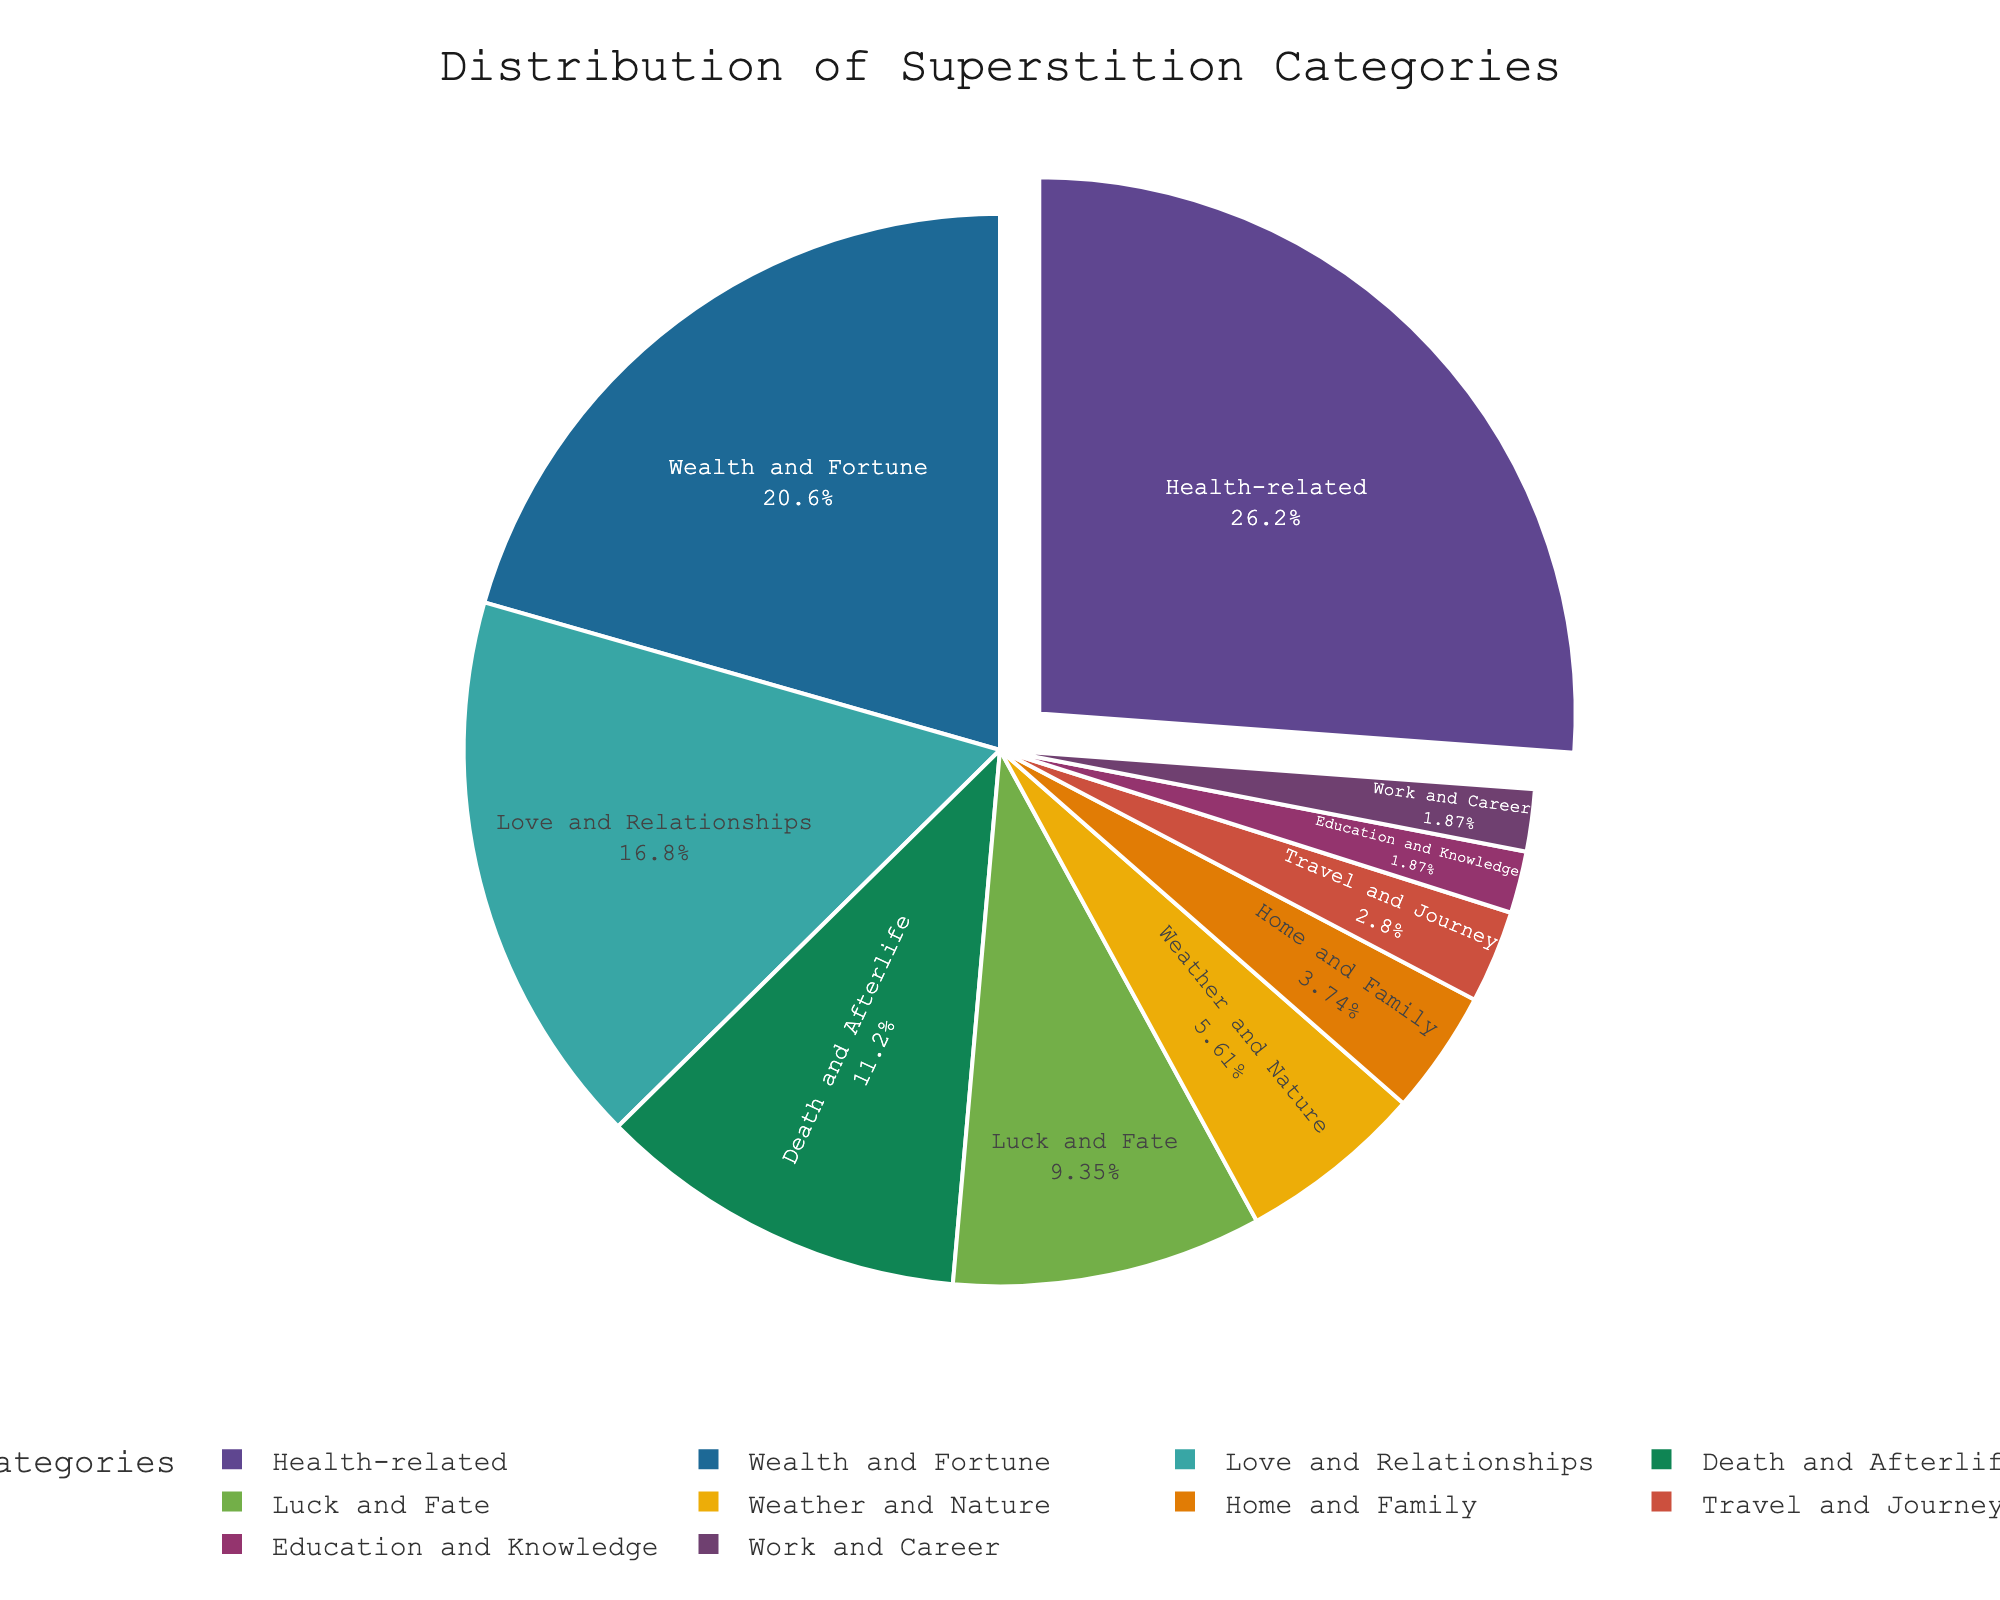What is the largest superstition category? The largest superstition category is represented by the largest slice of the pie chart. It is 'Health-related'.
Answer: Health-related Which category has the smallest proportion? The smallest proportion is represented by the smallest slice of the pie chart. It is 'Work and Career', represented by only 2%.
Answer: Work and Career What is the combined percentage of 'Health-related' and 'Wealth and Fortune'? The 'Health-related' category is 28% and 'Wealth and Fortune' is 22%. Combining these categories: 28% + 22% = 50%.
Answer: 50% Compare the percentages of 'Luck and Fate' and 'Love and Relationships'. Which one has a higher percentage? 'Luck and Fate' is 10% and 'Love and Relationships' is 18%. Since 18% is greater than 10%, 'Love and Relationships' has a higher percentage.
Answer: Love and Relationships Is the proportion of 'Weather and Nature' greater than 'Home and Family'? 'Weather and Nature' is 6% while 'Home and Family' is 4%. Since 6% is greater than 4%, 'Weather and Nature' has a greater proportion.
Answer: Yes What is the total percentage of categories related to personal matters ('Love and Relationships', 'Home and Family', 'Health-related')? The percentages are 18%, 4%, and 28% respectively. Summing these: 18% + 4% + 28% = 50%.
Answer: 50% How much smaller is the 'Education and Knowledge' category compared to 'Travel and Journey'? 'Education and Knowledge' is 2% and 'Travel and Journey' is 3%. The difference is 3% - 2% = 1%.
Answer: 1% Which categories have an equal percentage? The categories 'Education and Knowledge' and 'Work and Career' both are represented by 2%.
Answer: Education and Knowledge, Work and Career What is the visual difference between the slices representing 'Health-related' and 'Weather and Nature'? The 'Health-related' slice is much larger and is pulled out from the pie chart, while 'Weather and Nature' is smaller and remains inside.
Answer: 'Health-related' is larger and pulled out, 'Weather and Nature' is smaller and inside 